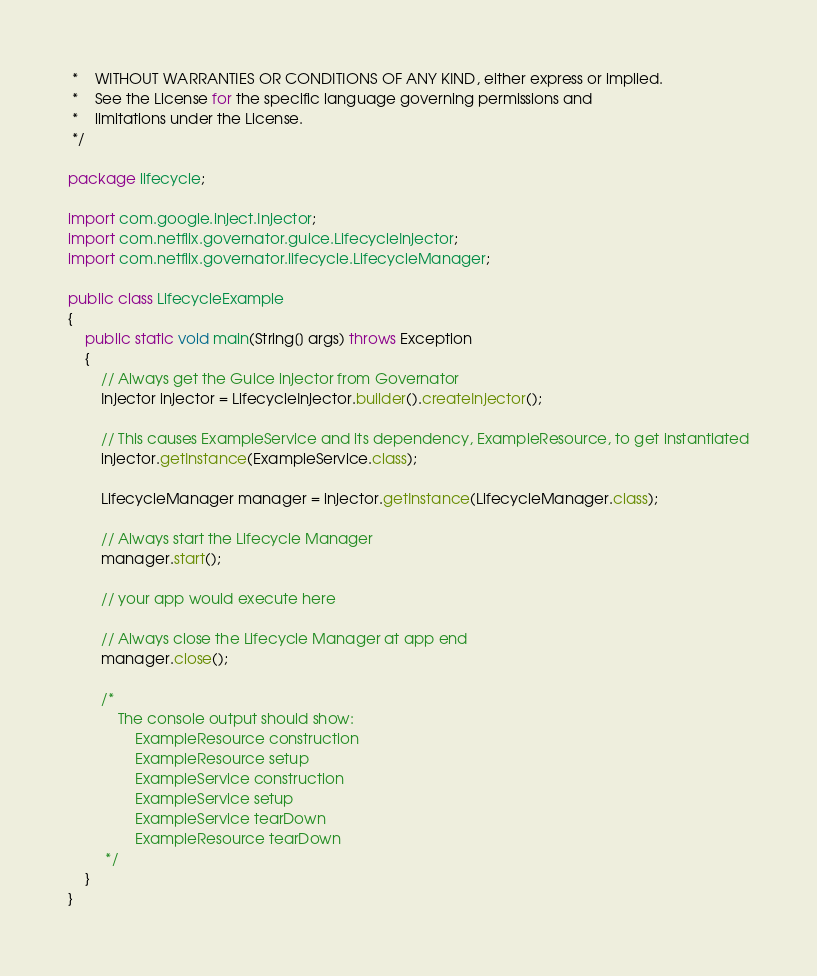Convert code to text. <code><loc_0><loc_0><loc_500><loc_500><_Java_> *    WITHOUT WARRANTIES OR CONDITIONS OF ANY KIND, either express or implied.
 *    See the License for the specific language governing permissions and
 *    limitations under the License.
 */

package lifecycle;

import com.google.inject.Injector;
import com.netflix.governator.guice.LifecycleInjector;
import com.netflix.governator.lifecycle.LifecycleManager;

public class LifecycleExample
{
    public static void main(String[] args) throws Exception
    {
        // Always get the Guice injector from Governator
        Injector injector = LifecycleInjector.builder().createInjector();

        // This causes ExampleService and its dependency, ExampleResource, to get instantiated
        injector.getInstance(ExampleService.class);

        LifecycleManager manager = injector.getInstance(LifecycleManager.class);

        // Always start the Lifecycle Manager
        manager.start();

        // your app would execute here

        // Always close the Lifecycle Manager at app end
        manager.close();

        /*
            The console output should show:
                ExampleResource construction
                ExampleResource setup
                ExampleService construction
                ExampleService setup
                ExampleService tearDown
                ExampleResource tearDown
         */
    }
}
</code> 